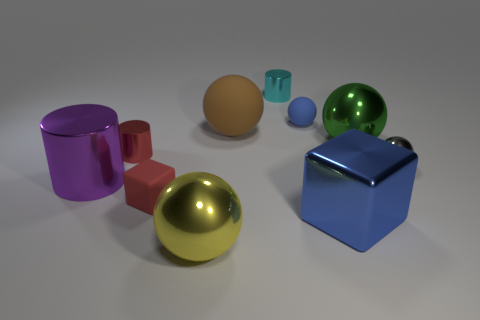There is a small shiny thing behind the green sphere; does it have the same shape as the blue metal thing?
Your response must be concise. No. What is the shape of the blue object that is in front of the large metallic ball to the right of the small blue matte object?
Make the answer very short. Cube. There is a blue metallic object right of the tiny thing that is behind the small ball behind the brown thing; what size is it?
Provide a short and direct response. Large. What is the color of the large matte object that is the same shape as the small gray thing?
Your response must be concise. Brown. Is the yellow object the same size as the green metallic sphere?
Ensure brevity in your answer.  Yes. What material is the cube to the right of the red cube?
Make the answer very short. Metal. What number of other things are the same shape as the big brown thing?
Give a very brief answer. 4. Are there the same number of purple matte balls and purple metallic cylinders?
Your response must be concise. No. Do the cyan metallic object and the brown rubber object have the same shape?
Keep it short and to the point. No. There is a gray thing; are there any metallic cylinders behind it?
Your response must be concise. Yes. 